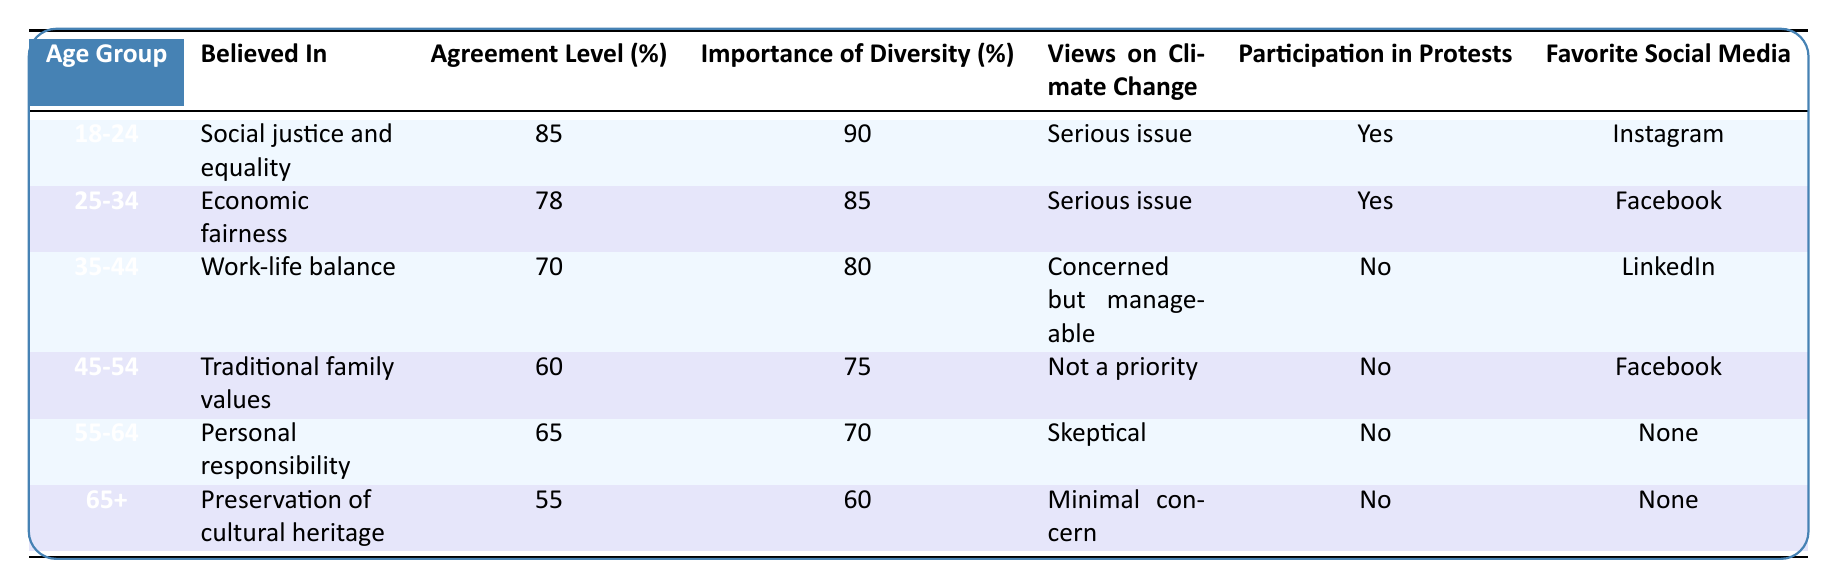What is the highest agreement level among the age groups? The highest agreement level is 85%, which is found in the 18-24 age group.
Answer: 85% What is the main belief of the 45-54 age group? The main belief of the 45-54 age group is "Traditional family values."
Answer: Traditional family values Which age group places the highest importance on diversity? The 18-24 age group places the highest importance on diversity, with a rating of 90%.
Answer: 18-24 Is there any age group that participates in protests? Yes, both the 18-24 and 25-34 age groups participate in protests.
Answer: Yes What is the average agreement level across all age groups? The agreement levels are 85, 78, 70, 60, 65, and 55. Their sum is 413. There are 6 groups, so the average is 413/6 = 68.83.
Answer: 68.83 Which age group has the lowest belief in diversity? The lowest importance of diversity is in the 65+ age group, at 60%.
Answer: 65+ Are younger age groups more likely to consider climate change a serious issue compared to older age groups? Yes, the younger age groups (18-24 and 25-34) view climate change as a serious issue, while older groups show less concern.
Answer: Yes How do the views on climate change differ between the 35-44 age group and the 55-64 age group? The 35-44 age group is "Concerned but manageable," while the 55-64 age group is "Skeptical," indicating more doubt about climate change in the latter.
Answer: More skeptical in the 55-64 age group What is the favorite social media platform for the 35-44 age group? The favorite social media platform for the 35-44 age group is LinkedIn.
Answer: LinkedIn Aside from the youngest group, which age group has the highest agreement level? The age group 25-34 has the highest agreement level after the 18-24 group, with 78%.
Answer: 25-34 What pattern can be observed about participation in protests across age groups? As age increases, participation in protests decreases, with only the two youngest groups participating.
Answer: Participation decreases with age 